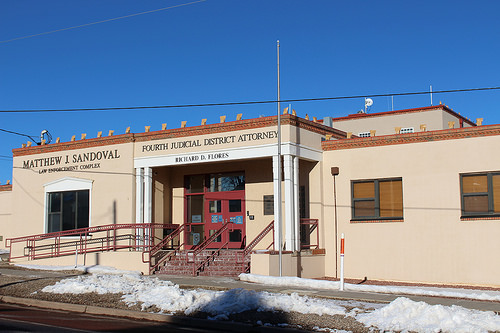<image>
Can you confirm if the door is on the stair? No. The door is not positioned on the stair. They may be near each other, but the door is not supported by or resting on top of the stair. Is there a steps under the sign? No. The steps is not positioned under the sign. The vertical relationship between these objects is different. 